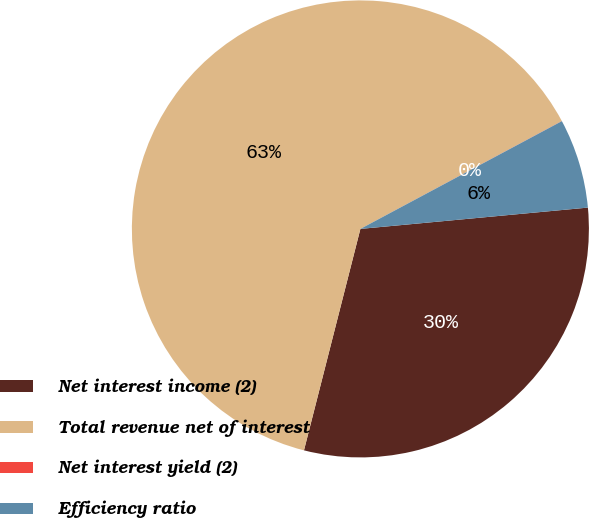Convert chart. <chart><loc_0><loc_0><loc_500><loc_500><pie_chart><fcel>Net interest income (2)<fcel>Total revenue net of interest<fcel>Net interest yield (2)<fcel>Efficiency ratio<nl><fcel>30.46%<fcel>63.21%<fcel>0.01%<fcel>6.33%<nl></chart> 